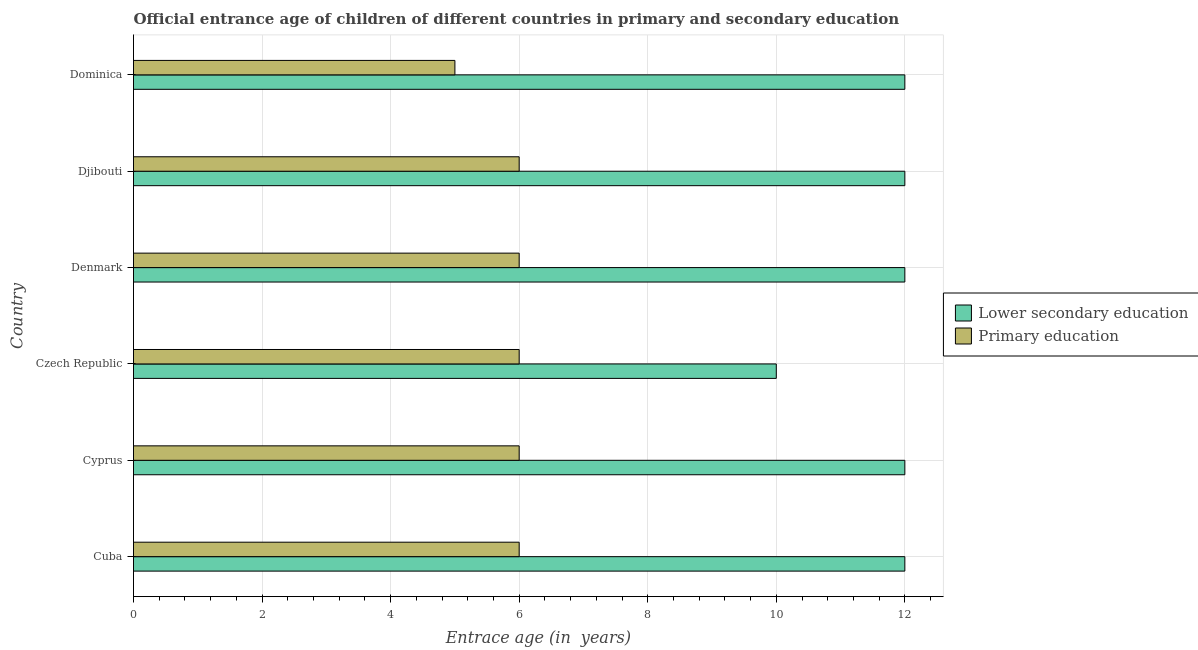How many different coloured bars are there?
Offer a very short reply. 2. Are the number of bars on each tick of the Y-axis equal?
Ensure brevity in your answer.  Yes. What is the label of the 6th group of bars from the top?
Your answer should be very brief. Cuba. In how many cases, is the number of bars for a given country not equal to the number of legend labels?
Make the answer very short. 0. What is the entrance age of children in lower secondary education in Cuba?
Your response must be concise. 12. Across all countries, what is the minimum entrance age of children in lower secondary education?
Your answer should be very brief. 10. In which country was the entrance age of chiildren in primary education maximum?
Provide a succinct answer. Cuba. In which country was the entrance age of chiildren in primary education minimum?
Give a very brief answer. Dominica. What is the total entrance age of chiildren in primary education in the graph?
Provide a short and direct response. 35. What is the difference between the entrance age of chiildren in primary education in Cyprus and that in Dominica?
Your response must be concise. 1. What is the difference between the entrance age of children in lower secondary education in Czech Republic and the entrance age of chiildren in primary education in Dominica?
Provide a short and direct response. 5. What is the average entrance age of children in lower secondary education per country?
Make the answer very short. 11.67. What is the difference between the entrance age of children in lower secondary education and entrance age of chiildren in primary education in Czech Republic?
Offer a terse response. 4. In how many countries, is the entrance age of chiildren in primary education greater than 12 years?
Offer a terse response. 0. What is the ratio of the entrance age of chiildren in primary education in Cyprus to that in Dominica?
Make the answer very short. 1.2. What is the difference between the highest and the lowest entrance age of chiildren in primary education?
Make the answer very short. 1. What does the 2nd bar from the top in Djibouti represents?
Your response must be concise. Lower secondary education. How many bars are there?
Your answer should be compact. 12. Are all the bars in the graph horizontal?
Offer a very short reply. Yes. How many countries are there in the graph?
Give a very brief answer. 6. What is the difference between two consecutive major ticks on the X-axis?
Your answer should be compact. 2. Where does the legend appear in the graph?
Your answer should be compact. Center right. What is the title of the graph?
Ensure brevity in your answer.  Official entrance age of children of different countries in primary and secondary education. Does "Researchers" appear as one of the legend labels in the graph?
Offer a very short reply. No. What is the label or title of the X-axis?
Offer a very short reply. Entrace age (in  years). What is the Entrace age (in  years) in Lower secondary education in Cuba?
Your response must be concise. 12. What is the Entrace age (in  years) of Primary education in Cuba?
Keep it short and to the point. 6. What is the Entrace age (in  years) of Primary education in Czech Republic?
Offer a terse response. 6. What is the Entrace age (in  years) in Primary education in Denmark?
Offer a terse response. 6. What is the Entrace age (in  years) in Lower secondary education in Djibouti?
Make the answer very short. 12. What is the Entrace age (in  years) in Primary education in Djibouti?
Provide a succinct answer. 6. What is the Entrace age (in  years) of Primary education in Dominica?
Offer a very short reply. 5. Across all countries, what is the minimum Entrace age (in  years) in Lower secondary education?
Provide a succinct answer. 10. What is the total Entrace age (in  years) of Lower secondary education in the graph?
Provide a short and direct response. 70. What is the total Entrace age (in  years) of Primary education in the graph?
Your answer should be very brief. 35. What is the difference between the Entrace age (in  years) in Lower secondary education in Cuba and that in Denmark?
Offer a very short reply. 0. What is the difference between the Entrace age (in  years) of Primary education in Cuba and that in Dominica?
Provide a short and direct response. 1. What is the difference between the Entrace age (in  years) of Primary education in Cyprus and that in Czech Republic?
Offer a very short reply. 0. What is the difference between the Entrace age (in  years) in Lower secondary education in Cyprus and that in Djibouti?
Keep it short and to the point. 0. What is the difference between the Entrace age (in  years) of Primary education in Cyprus and that in Djibouti?
Your answer should be compact. 0. What is the difference between the Entrace age (in  years) of Lower secondary education in Cyprus and that in Dominica?
Your response must be concise. 0. What is the difference between the Entrace age (in  years) of Primary education in Cyprus and that in Dominica?
Offer a very short reply. 1. What is the difference between the Entrace age (in  years) of Lower secondary education in Czech Republic and that in Denmark?
Provide a succinct answer. -2. What is the difference between the Entrace age (in  years) of Primary education in Czech Republic and that in Denmark?
Give a very brief answer. 0. What is the difference between the Entrace age (in  years) in Lower secondary education in Czech Republic and that in Djibouti?
Your answer should be compact. -2. What is the difference between the Entrace age (in  years) in Primary education in Czech Republic and that in Djibouti?
Offer a very short reply. 0. What is the difference between the Entrace age (in  years) of Lower secondary education in Denmark and that in Djibouti?
Offer a very short reply. 0. What is the difference between the Entrace age (in  years) in Lower secondary education in Cuba and the Entrace age (in  years) in Primary education in Czech Republic?
Offer a very short reply. 6. What is the difference between the Entrace age (in  years) in Lower secondary education in Cuba and the Entrace age (in  years) in Primary education in Djibouti?
Your answer should be compact. 6. What is the difference between the Entrace age (in  years) in Lower secondary education in Cyprus and the Entrace age (in  years) in Primary education in Czech Republic?
Provide a succinct answer. 6. What is the difference between the Entrace age (in  years) of Lower secondary education in Cyprus and the Entrace age (in  years) of Primary education in Denmark?
Make the answer very short. 6. What is the difference between the Entrace age (in  years) of Lower secondary education in Cyprus and the Entrace age (in  years) of Primary education in Dominica?
Your response must be concise. 7. What is the difference between the Entrace age (in  years) of Lower secondary education in Czech Republic and the Entrace age (in  years) of Primary education in Dominica?
Your answer should be compact. 5. What is the difference between the Entrace age (in  years) in Lower secondary education in Denmark and the Entrace age (in  years) in Primary education in Dominica?
Keep it short and to the point. 7. What is the difference between the Entrace age (in  years) of Lower secondary education in Djibouti and the Entrace age (in  years) of Primary education in Dominica?
Your answer should be very brief. 7. What is the average Entrace age (in  years) of Lower secondary education per country?
Make the answer very short. 11.67. What is the average Entrace age (in  years) in Primary education per country?
Keep it short and to the point. 5.83. What is the difference between the Entrace age (in  years) in Lower secondary education and Entrace age (in  years) in Primary education in Cyprus?
Your answer should be compact. 6. What is the difference between the Entrace age (in  years) in Lower secondary education and Entrace age (in  years) in Primary education in Denmark?
Offer a very short reply. 6. What is the ratio of the Entrace age (in  years) of Primary education in Cuba to that in Cyprus?
Ensure brevity in your answer.  1. What is the ratio of the Entrace age (in  years) of Primary education in Cuba to that in Czech Republic?
Offer a terse response. 1. What is the ratio of the Entrace age (in  years) of Lower secondary education in Cuba to that in Djibouti?
Offer a very short reply. 1. What is the ratio of the Entrace age (in  years) of Primary education in Cuba to that in Djibouti?
Make the answer very short. 1. What is the ratio of the Entrace age (in  years) in Lower secondary education in Cuba to that in Dominica?
Your answer should be compact. 1. What is the ratio of the Entrace age (in  years) of Lower secondary education in Cyprus to that in Djibouti?
Give a very brief answer. 1. What is the ratio of the Entrace age (in  years) of Primary education in Cyprus to that in Djibouti?
Ensure brevity in your answer.  1. What is the ratio of the Entrace age (in  years) of Lower secondary education in Cyprus to that in Dominica?
Ensure brevity in your answer.  1. What is the ratio of the Entrace age (in  years) of Lower secondary education in Czech Republic to that in Denmark?
Ensure brevity in your answer.  0.83. What is the ratio of the Entrace age (in  years) in Primary education in Czech Republic to that in Denmark?
Offer a very short reply. 1. What is the ratio of the Entrace age (in  years) of Lower secondary education in Czech Republic to that in Djibouti?
Offer a very short reply. 0.83. What is the ratio of the Entrace age (in  years) of Lower secondary education in Czech Republic to that in Dominica?
Make the answer very short. 0.83. What is the ratio of the Entrace age (in  years) in Lower secondary education in Denmark to that in Djibouti?
Your response must be concise. 1. What is the ratio of the Entrace age (in  years) of Primary education in Denmark to that in Dominica?
Give a very brief answer. 1.2. What is the ratio of the Entrace age (in  years) in Primary education in Djibouti to that in Dominica?
Offer a terse response. 1.2. What is the difference between the highest and the second highest Entrace age (in  years) in Lower secondary education?
Your answer should be compact. 0. What is the difference between the highest and the second highest Entrace age (in  years) in Primary education?
Give a very brief answer. 0. What is the difference between the highest and the lowest Entrace age (in  years) in Primary education?
Offer a terse response. 1. 